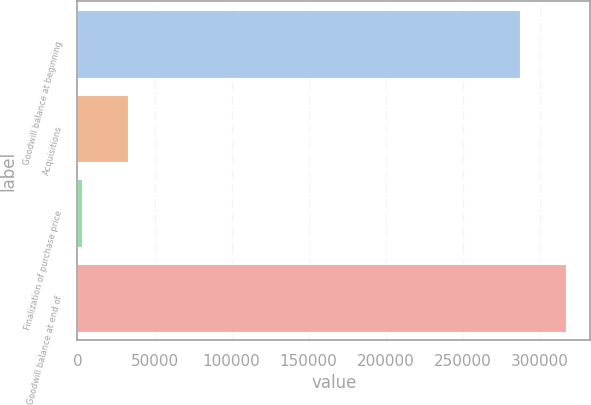Convert chart to OTSL. <chart><loc_0><loc_0><loc_500><loc_500><bar_chart><fcel>Goodwill balance at beginning<fcel>Acquisitions<fcel>Finalization of purchase price<fcel>Goodwill balance at end of<nl><fcel>286982<fcel>32561.4<fcel>2733<fcel>316810<nl></chart> 